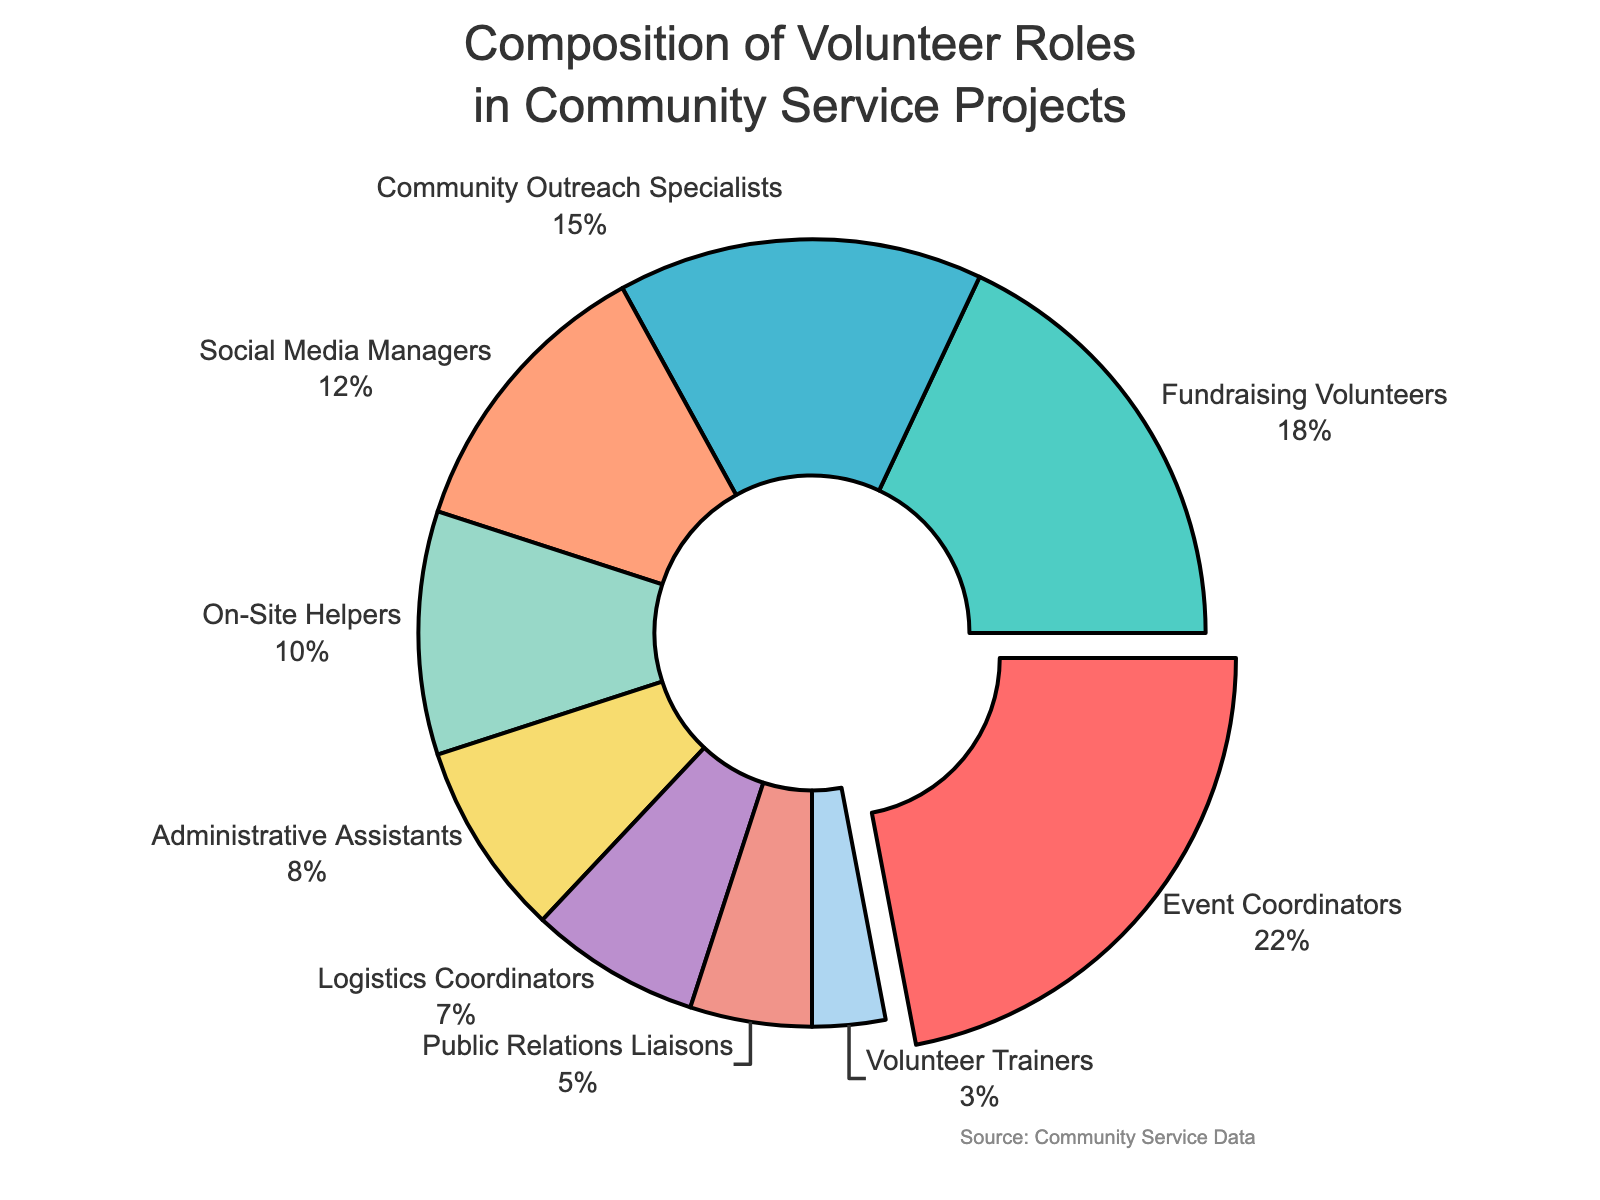Which volunteer role has the highest percentage? The pie chart shows different volunteer roles with their corresponding percentages. The largest segment visually noted with a slight pull-out is Event Coordinators at 22%.
Answer: Event Coordinators Which role has the lowest percentage? By looking at the pie chart, the smallest segment is Volunteer Trainers with a percentage of 3%.
Answer: Volunteer Trainers What is the combined percentage of Fundraising Volunteers and Community Outreach Specialists? The percentages of Fundraising Volunteers and Community Outreach Specialists are 18% and 15% respectively. Adding them together gives 18% + 15% = 33%.
Answer: 33% Which roles have a combined percentage higher: Social Media Managers and Administrative Assistants or On-Site Helpers and Logistics Coordinators? The percentages for Social Media Managers and Administrative Assistants are 12% and 8% respectively, totaling 20%. For On-Site Helpers and Logistics Coordinators, the percentages are 10% and 7%, totaling 17%. 20% is greater than 17%.
Answer: Social Media Managers and Administrative Assistants What is the percentage difference between Event Coordinators and Public Relations Liaisons? The percentage for Event Coordinators is 22% and for Public Relations Liaisons it is 5%. The difference is 22% - 5% = 17%.
Answer: 17% Which segment is colored yellow, and what is its percentage? The segment colored yellow represents Administrative Assistants, with a percentage of 8%.
Answer: Administrative Assistants, 8% Are there more On-Site Helpers or Logistics Coordinators, and by what percentage? The percentage of On-Site Helpers is 10% and that of Logistics Coordinators is 7%. The difference is 10% - 7% = 3%.
Answer: On-Site Helpers, 3% What is the total percentage of volunteers involved in roles related to event logistics (Event Coordinators and Logistics Coordinators)? The percentages for Event Coordinators and Logistics Coordinators are 22% and 7% respectively. Adding them gives 22% + 7% = 29%.
Answer: 29% If we group Fundraising Volunteers and Public Relations Liaisons, will their combined percentage surpass that of Event Coordinators? The combined percentage for Fundraising Volunteers and Public Relations Liaisons is 18% + 5% = 23%, which is greater than the 22% of Event Coordinators.
Answer: Yes, 1% more What percentage of volunteers are involved in roles not directly specifying communication tasks (excluding Community Outreach Specialists, Social Media Managers, and Public Relations Liaisons)? Summing the percentages of Event Coordinators, Fundraising Volunteers, On-Site Helpers, Administrative Assistants, Logistics Coordinators, and Volunteer Trainers: 22% + 18% + 10% + 8% + 7% + 3% = 68%.
Answer: 68% 